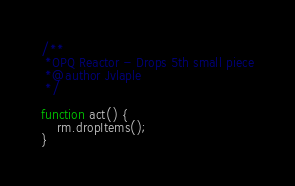<code> <loc_0><loc_0><loc_500><loc_500><_JavaScript_>/**
 *OPQ Reactor - Drops 5th small piece
 *@author Jvlaple
 */

function act() {
	rm.dropItems();
}</code> 